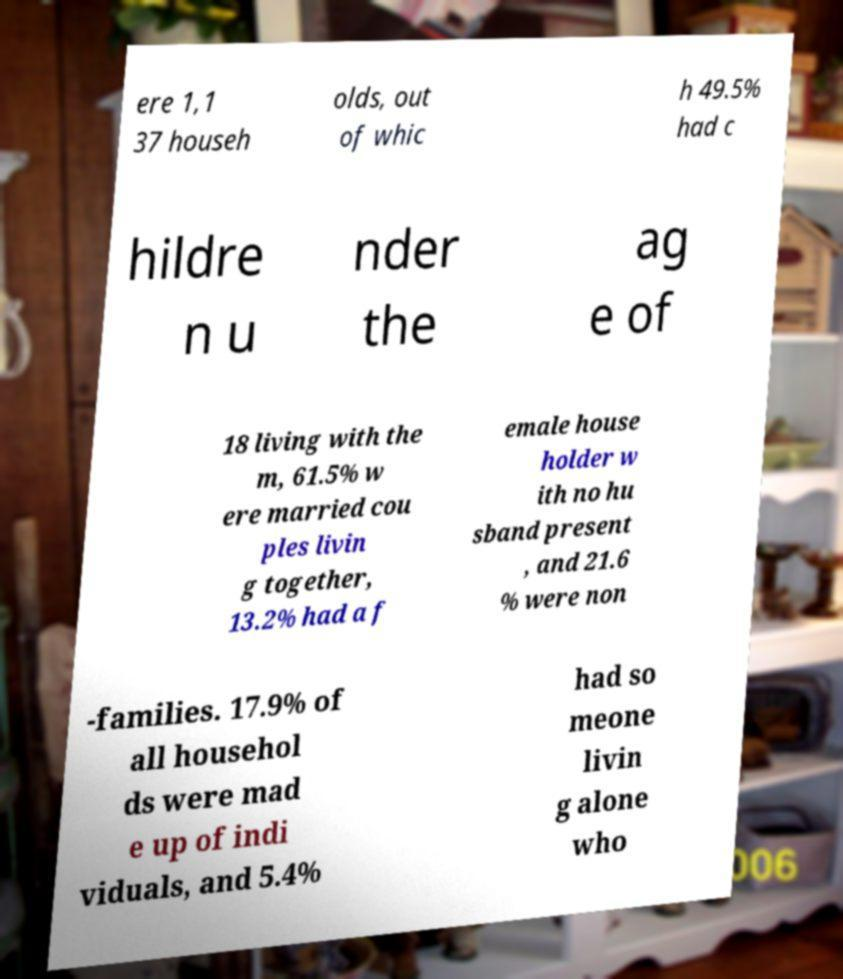There's text embedded in this image that I need extracted. Can you transcribe it verbatim? ere 1,1 37 househ olds, out of whic h 49.5% had c hildre n u nder the ag e of 18 living with the m, 61.5% w ere married cou ples livin g together, 13.2% had a f emale house holder w ith no hu sband present , and 21.6 % were non -families. 17.9% of all househol ds were mad e up of indi viduals, and 5.4% had so meone livin g alone who 